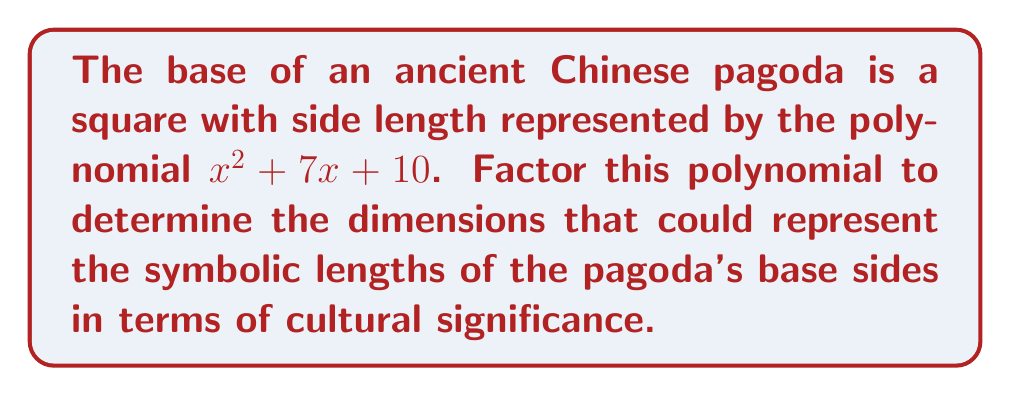Show me your answer to this math problem. To factor this polynomial, we'll follow these steps:

1) The polynomial is in the form $x^2 + bx + c$, where $b = 7$ and $c = 10$.

2) We need to find two numbers that multiply to give $c$ (10) and add up to $b$ (7).

3) The factors of 10 are: 1 and 10, 2 and 5.

4) Among these, 2 and 5 add up to 7.

5) Therefore, we can rewrite the middle term as:
   $x^2 + 7x + 10 = x^2 + 2x + 5x + 10$

6) Now we can group the terms:
   $(x^2 + 2x) + (5x + 10)$

7) Factor out the common factors from each group:
   $x(x + 2) + 5(x + 2)$

8) We can now factor out the common binomial $(x + 2)$:
   $(x + 2)(x + 5)$

Thus, the factored form of $x^2 + 7x + 10$ is $(x + 2)(x + 5)$.

In the context of East Asian architecture, this factorization could represent the symbolic dimensions of the pagoda's base. The factors $(x + 2)$ and $(x + 5)$ might represent cultural or religious significances, such as the Two Truths in Buddhism (2) and the Five Elements in Chinese philosophy (5).
Answer: $(x + 2)(x + 5)$ 